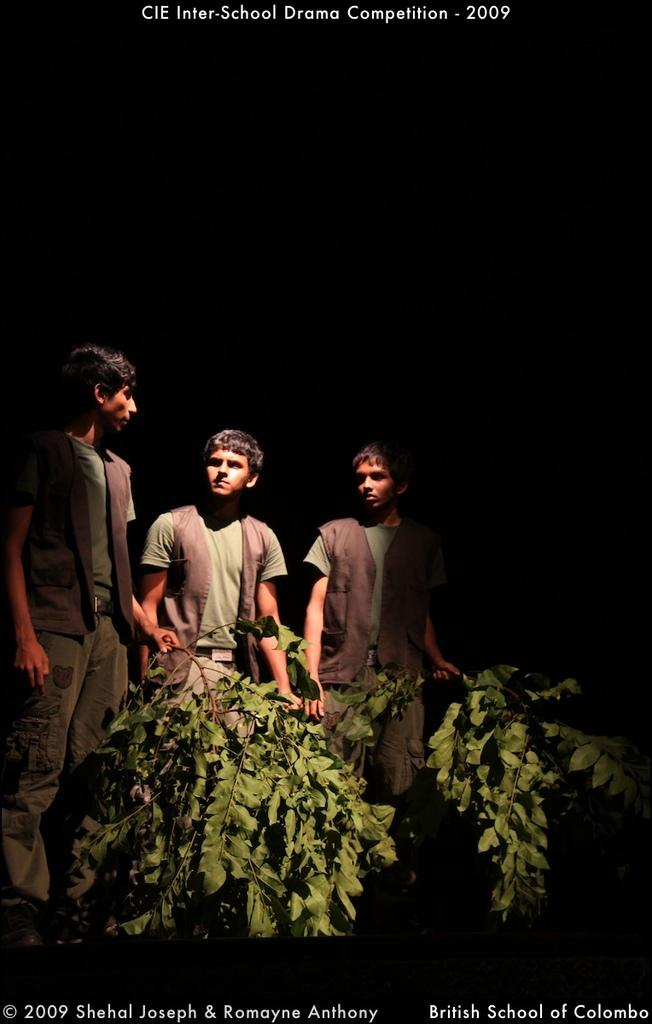How many people are in the image? There are three persons in the image. What are the persons wearing? The persons are wearing dresses. What are the persons doing in the image? The persons are standing and holding the branch of a tree. What can be observed about the tree branch? The tree branch contains leaves. What type of fuel is being used by the persons in the image? There is no indication in the image that the persons are using any type of fuel. How many sides does the sugar cube have in the image? There is no sugar cube present in the image. 